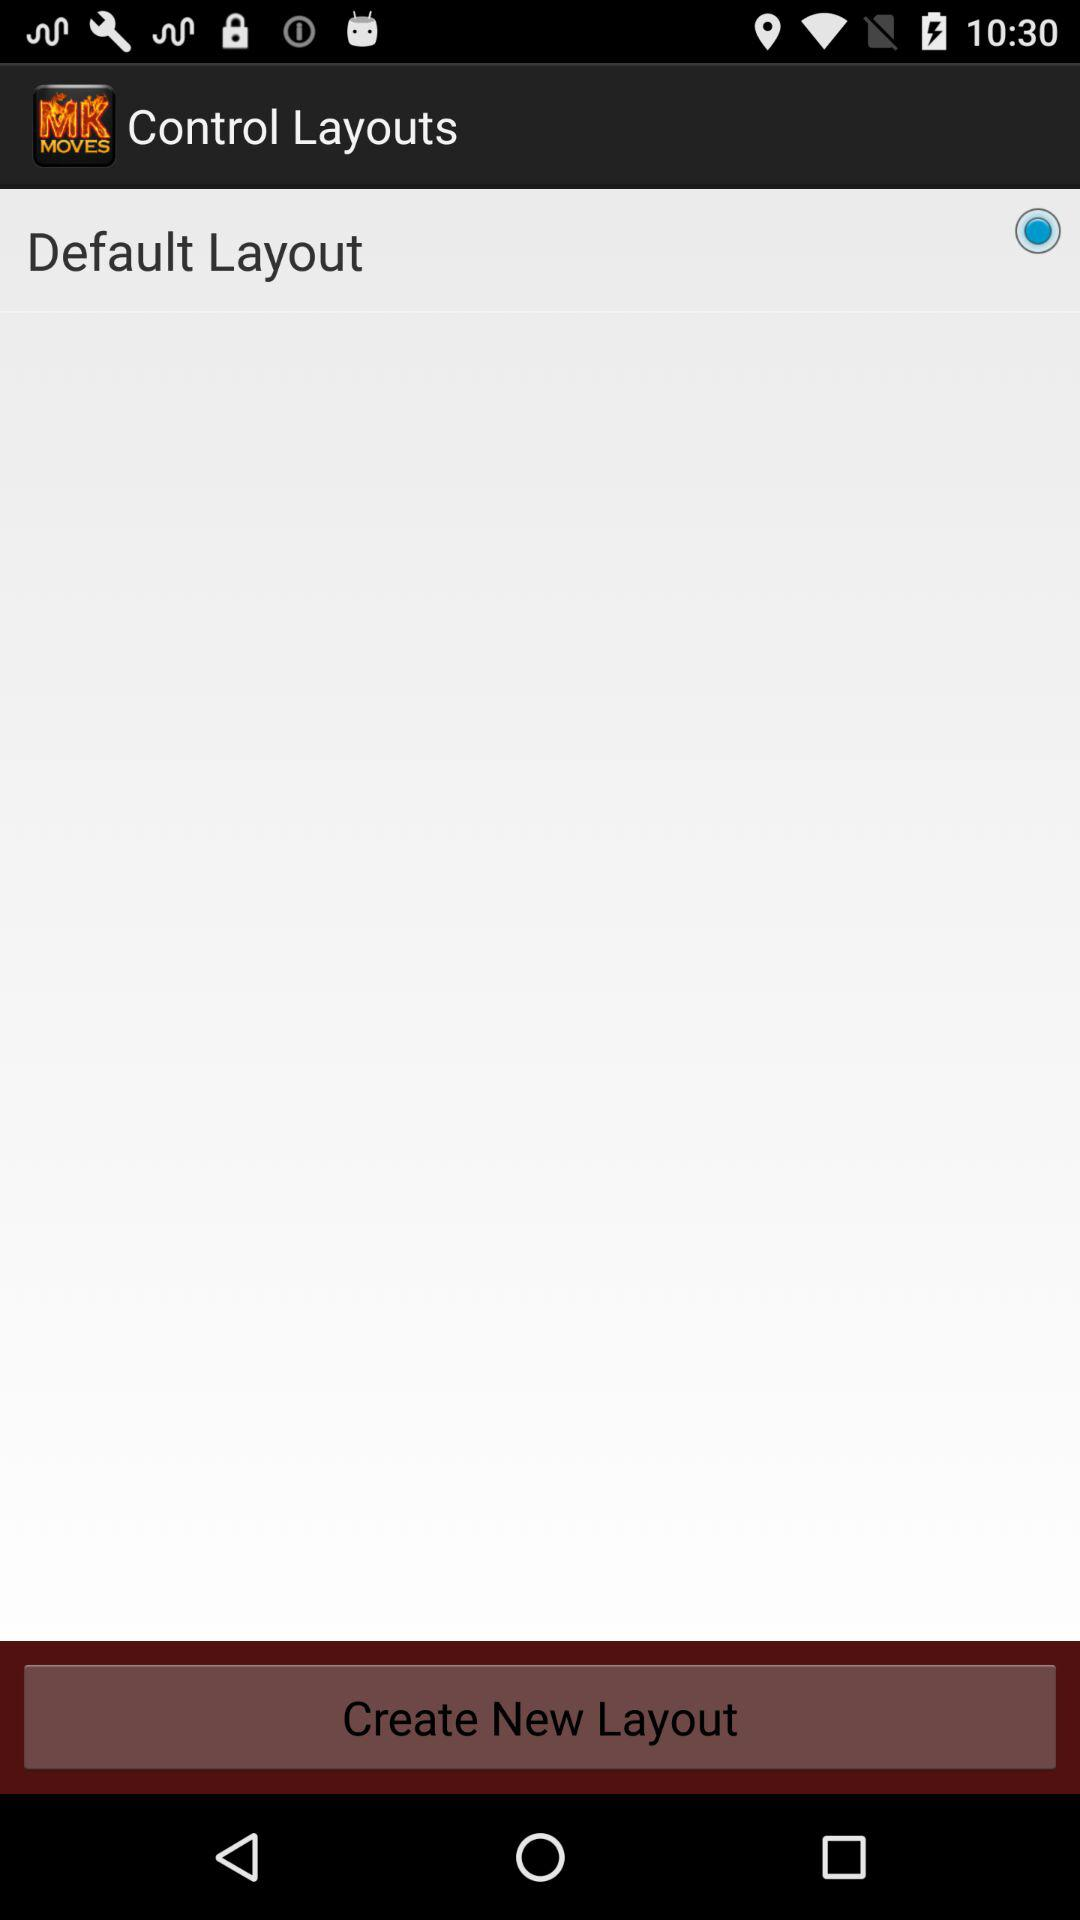Is "Default Layout" selected or not?
Answer the question using a single word or phrase. It is selected. 